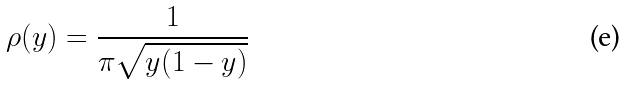<formula> <loc_0><loc_0><loc_500><loc_500>\rho ( y ) = \frac { 1 } { \pi \sqrt { y ( 1 - y ) } } \,</formula> 